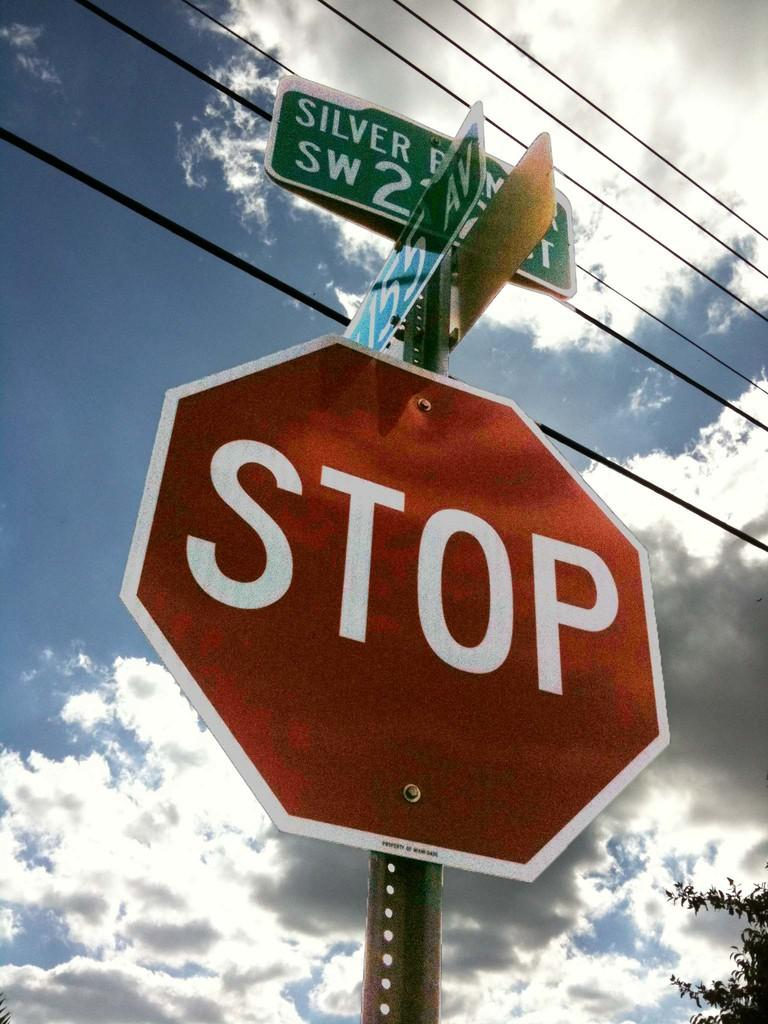<image>
Create a compact narrative representing the image presented. A stop sign is shown under a blue sky with clouds. 